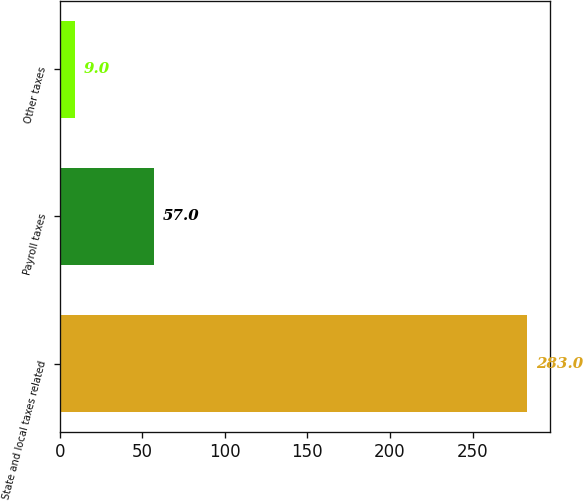<chart> <loc_0><loc_0><loc_500><loc_500><bar_chart><fcel>State and local taxes related<fcel>Payroll taxes<fcel>Other taxes<nl><fcel>283<fcel>57<fcel>9<nl></chart> 